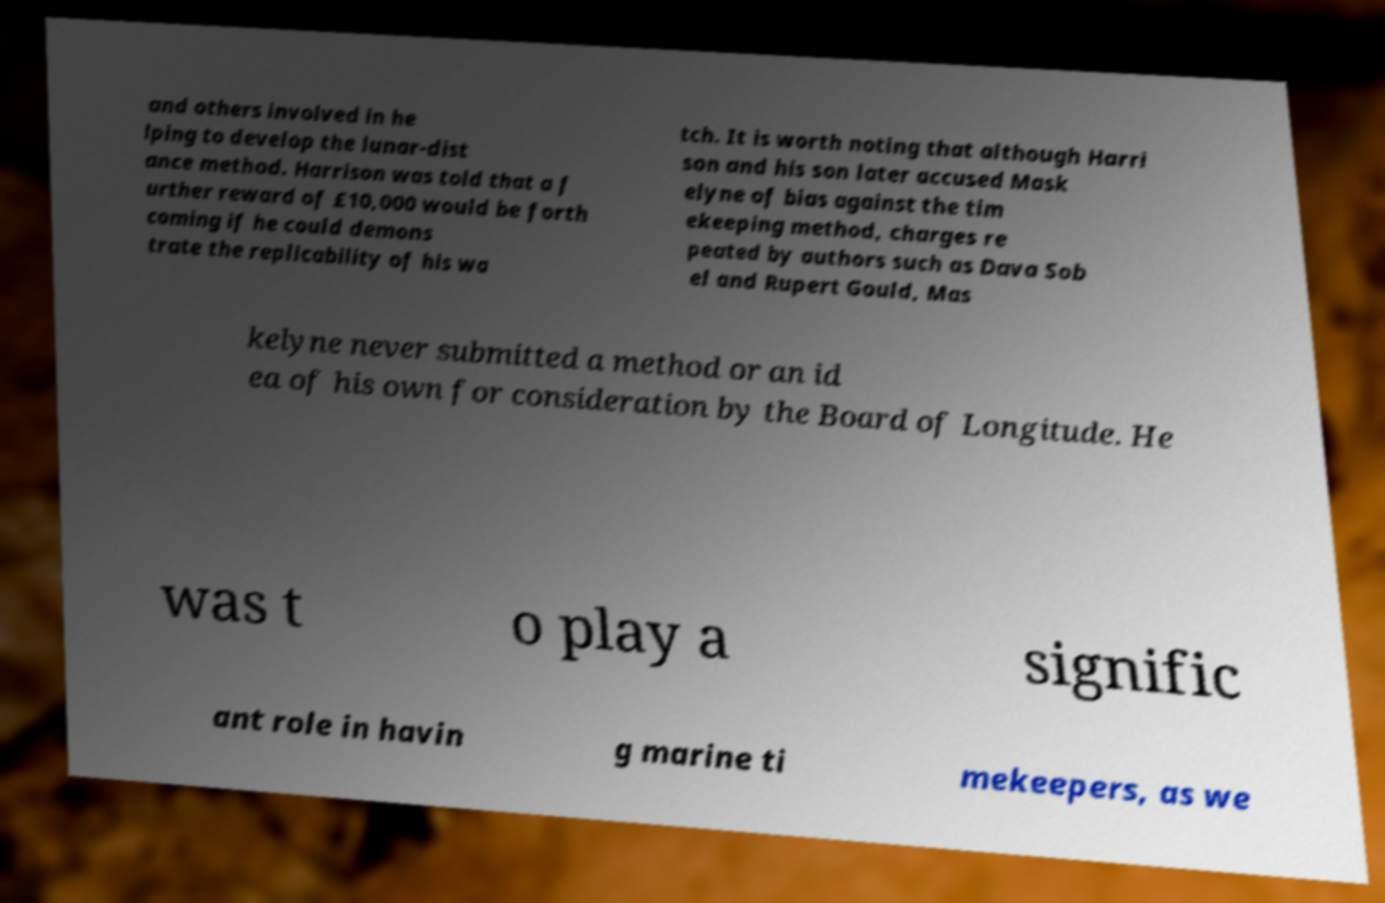Can you read and provide the text displayed in the image?This photo seems to have some interesting text. Can you extract and type it out for me? and others involved in he lping to develop the lunar-dist ance method. Harrison was told that a f urther reward of £10,000 would be forth coming if he could demons trate the replicability of his wa tch. It is worth noting that although Harri son and his son later accused Mask elyne of bias against the tim ekeeping method, charges re peated by authors such as Dava Sob el and Rupert Gould, Mas kelyne never submitted a method or an id ea of his own for consideration by the Board of Longitude. He was t o play a signific ant role in havin g marine ti mekeepers, as we 